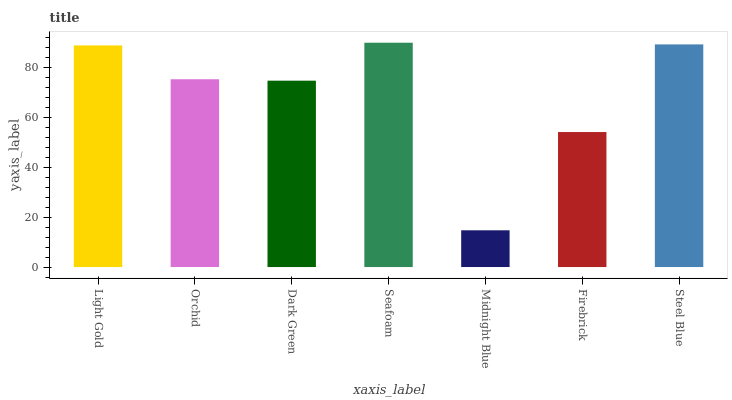Is Midnight Blue the minimum?
Answer yes or no. Yes. Is Seafoam the maximum?
Answer yes or no. Yes. Is Orchid the minimum?
Answer yes or no. No. Is Orchid the maximum?
Answer yes or no. No. Is Light Gold greater than Orchid?
Answer yes or no. Yes. Is Orchid less than Light Gold?
Answer yes or no. Yes. Is Orchid greater than Light Gold?
Answer yes or no. No. Is Light Gold less than Orchid?
Answer yes or no. No. Is Orchid the high median?
Answer yes or no. Yes. Is Orchid the low median?
Answer yes or no. Yes. Is Steel Blue the high median?
Answer yes or no. No. Is Firebrick the low median?
Answer yes or no. No. 